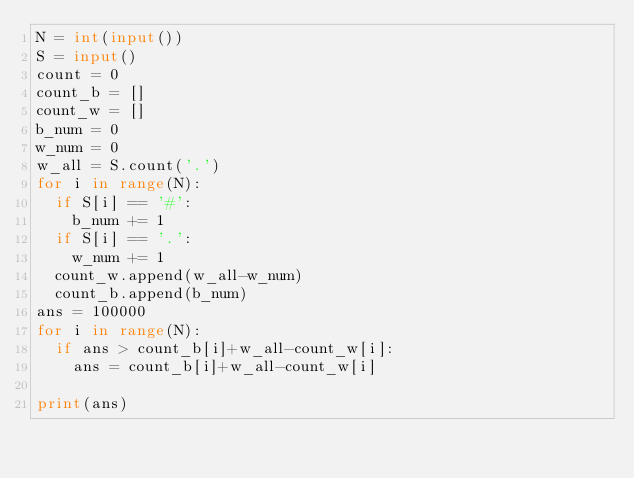<code> <loc_0><loc_0><loc_500><loc_500><_Python_>N = int(input())
S = input()
count = 0
count_b = []
count_w = []
b_num = 0
w_num = 0
w_all = S.count('.')
for i in range(N):
  if S[i] == '#':
    b_num += 1
  if S[i] == '.':
    w_num += 1
  count_w.append(w_all-w_num)
  count_b.append(b_num)
ans = 100000
for i in range(N):
  if ans > count_b[i]+w_all-count_w[i]:
    ans = count_b[i]+w_all-count_w[i]

print(ans)
</code> 